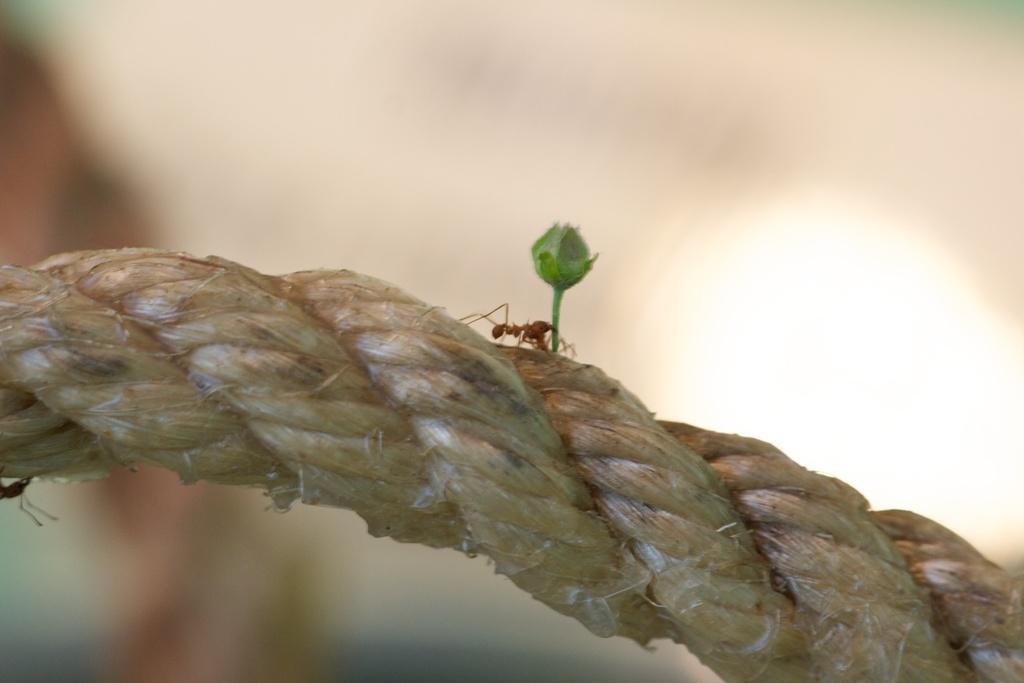Could you give a brief overview of what you see in this image? In this image there are red color ants on the rope, bud , and there is blur background. 